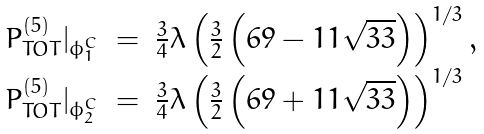<formula> <loc_0><loc_0><loc_500><loc_500>\begin{array} { r c l } P ^ { ( 5 ) } _ { T O T } | _ { \phi _ { 1 } ^ { C } } & = & \frac { 3 } { 4 } \lambda \left ( \frac { 3 } { 2 } \left ( 6 9 - 1 1 \sqrt { 3 3 } \right ) \right ) ^ { 1 / 3 } , \\ P ^ { ( 5 ) } _ { T O T } | _ { \phi _ { 2 } ^ { C } } & = & \frac { 3 } { 4 } \lambda \left ( \frac { 3 } { 2 } \left ( 6 9 + 1 1 \sqrt { 3 3 } \right ) \right ) ^ { 1 / 3 } \end{array}</formula> 